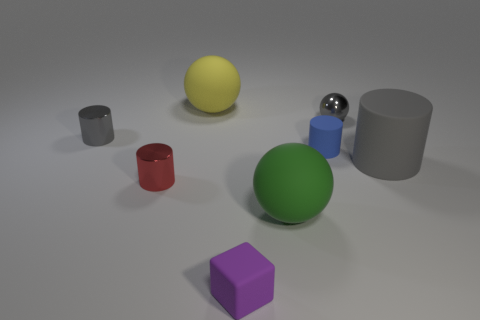How many big purple things have the same shape as the yellow matte thing? There is one big purple object in the image, which is a cube. This shape does not match the yellow matte object, which is a sphere. Therefore, there are no big purple things with the same shape as the yellow matte sphere. 